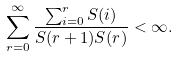Convert formula to latex. <formula><loc_0><loc_0><loc_500><loc_500>\sum _ { r = 0 } ^ { \infty } \frac { \sum _ { i = 0 } ^ { r } S ( i ) } { S ( r + 1 ) S ( r ) } < \infty .</formula> 